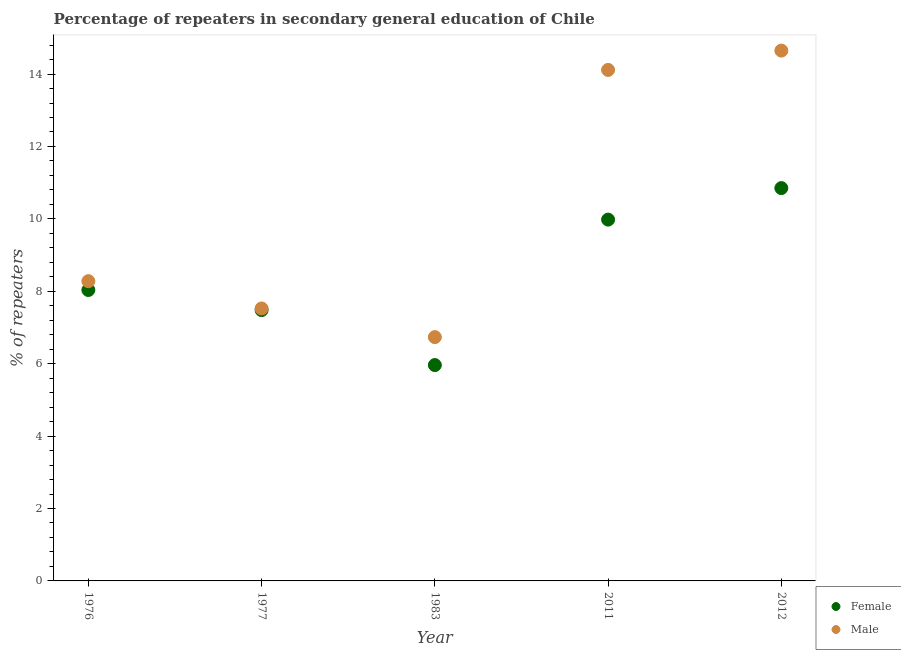How many different coloured dotlines are there?
Provide a short and direct response. 2. Is the number of dotlines equal to the number of legend labels?
Your response must be concise. Yes. What is the percentage of female repeaters in 2011?
Ensure brevity in your answer.  9.98. Across all years, what is the maximum percentage of male repeaters?
Ensure brevity in your answer.  14.65. Across all years, what is the minimum percentage of male repeaters?
Make the answer very short. 6.73. What is the total percentage of female repeaters in the graph?
Your response must be concise. 42.31. What is the difference between the percentage of female repeaters in 1976 and that in 1983?
Keep it short and to the point. 2.07. What is the difference between the percentage of male repeaters in 1983 and the percentage of female repeaters in 1977?
Your response must be concise. -0.75. What is the average percentage of male repeaters per year?
Offer a very short reply. 10.26. In the year 2011, what is the difference between the percentage of male repeaters and percentage of female repeaters?
Provide a short and direct response. 4.13. In how many years, is the percentage of female repeaters greater than 14.4 %?
Ensure brevity in your answer.  0. What is the ratio of the percentage of female repeaters in 1983 to that in 2012?
Provide a succinct answer. 0.55. Is the percentage of male repeaters in 1976 less than that in 1983?
Your response must be concise. No. What is the difference between the highest and the second highest percentage of male repeaters?
Your answer should be compact. 0.53. What is the difference between the highest and the lowest percentage of male repeaters?
Your response must be concise. 7.91. Is the sum of the percentage of female repeaters in 1983 and 2011 greater than the maximum percentage of male repeaters across all years?
Provide a short and direct response. Yes. Is the percentage of male repeaters strictly greater than the percentage of female repeaters over the years?
Provide a short and direct response. Yes. Is the percentage of female repeaters strictly less than the percentage of male repeaters over the years?
Your answer should be compact. Yes. How many years are there in the graph?
Keep it short and to the point. 5. Are the values on the major ticks of Y-axis written in scientific E-notation?
Your answer should be very brief. No. Does the graph contain grids?
Make the answer very short. No. How many legend labels are there?
Provide a succinct answer. 2. How are the legend labels stacked?
Your answer should be compact. Vertical. What is the title of the graph?
Keep it short and to the point. Percentage of repeaters in secondary general education of Chile. What is the label or title of the Y-axis?
Your response must be concise. % of repeaters. What is the % of repeaters of Female in 1976?
Your response must be concise. 8.04. What is the % of repeaters in Male in 1976?
Offer a very short reply. 8.28. What is the % of repeaters in Female in 1977?
Make the answer very short. 7.48. What is the % of repeaters in Male in 1977?
Provide a short and direct response. 7.53. What is the % of repeaters in Female in 1983?
Keep it short and to the point. 5.96. What is the % of repeaters in Male in 1983?
Make the answer very short. 6.73. What is the % of repeaters of Female in 2011?
Ensure brevity in your answer.  9.98. What is the % of repeaters in Male in 2011?
Keep it short and to the point. 14.11. What is the % of repeaters in Female in 2012?
Offer a terse response. 10.85. What is the % of repeaters of Male in 2012?
Provide a succinct answer. 14.65. Across all years, what is the maximum % of repeaters of Female?
Ensure brevity in your answer.  10.85. Across all years, what is the maximum % of repeaters of Male?
Provide a short and direct response. 14.65. Across all years, what is the minimum % of repeaters in Female?
Make the answer very short. 5.96. Across all years, what is the minimum % of repeaters in Male?
Your answer should be very brief. 6.73. What is the total % of repeaters in Female in the graph?
Your answer should be compact. 42.31. What is the total % of repeaters in Male in the graph?
Provide a short and direct response. 51.3. What is the difference between the % of repeaters in Female in 1976 and that in 1977?
Offer a terse response. 0.55. What is the difference between the % of repeaters in Male in 1976 and that in 1977?
Provide a short and direct response. 0.75. What is the difference between the % of repeaters in Female in 1976 and that in 1983?
Make the answer very short. 2.07. What is the difference between the % of repeaters in Male in 1976 and that in 1983?
Provide a succinct answer. 1.55. What is the difference between the % of repeaters in Female in 1976 and that in 2011?
Give a very brief answer. -1.94. What is the difference between the % of repeaters in Male in 1976 and that in 2011?
Make the answer very short. -5.83. What is the difference between the % of repeaters in Female in 1976 and that in 2012?
Your response must be concise. -2.81. What is the difference between the % of repeaters in Male in 1976 and that in 2012?
Offer a terse response. -6.37. What is the difference between the % of repeaters in Female in 1977 and that in 1983?
Make the answer very short. 1.52. What is the difference between the % of repeaters in Male in 1977 and that in 1983?
Provide a short and direct response. 0.79. What is the difference between the % of repeaters in Female in 1977 and that in 2011?
Your response must be concise. -2.5. What is the difference between the % of repeaters in Male in 1977 and that in 2011?
Your answer should be compact. -6.59. What is the difference between the % of repeaters of Female in 1977 and that in 2012?
Make the answer very short. -3.37. What is the difference between the % of repeaters of Male in 1977 and that in 2012?
Offer a very short reply. -7.12. What is the difference between the % of repeaters in Female in 1983 and that in 2011?
Your response must be concise. -4.02. What is the difference between the % of repeaters in Male in 1983 and that in 2011?
Your answer should be compact. -7.38. What is the difference between the % of repeaters of Female in 1983 and that in 2012?
Offer a very short reply. -4.89. What is the difference between the % of repeaters in Male in 1983 and that in 2012?
Provide a short and direct response. -7.91. What is the difference between the % of repeaters in Female in 2011 and that in 2012?
Your answer should be very brief. -0.87. What is the difference between the % of repeaters of Male in 2011 and that in 2012?
Provide a succinct answer. -0.53. What is the difference between the % of repeaters of Female in 1976 and the % of repeaters of Male in 1977?
Your response must be concise. 0.51. What is the difference between the % of repeaters in Female in 1976 and the % of repeaters in Male in 1983?
Give a very brief answer. 1.3. What is the difference between the % of repeaters in Female in 1976 and the % of repeaters in Male in 2011?
Provide a short and direct response. -6.08. What is the difference between the % of repeaters in Female in 1976 and the % of repeaters in Male in 2012?
Your answer should be very brief. -6.61. What is the difference between the % of repeaters in Female in 1977 and the % of repeaters in Male in 1983?
Your answer should be compact. 0.75. What is the difference between the % of repeaters in Female in 1977 and the % of repeaters in Male in 2011?
Make the answer very short. -6.63. What is the difference between the % of repeaters of Female in 1977 and the % of repeaters of Male in 2012?
Your answer should be compact. -7.17. What is the difference between the % of repeaters of Female in 1983 and the % of repeaters of Male in 2011?
Offer a terse response. -8.15. What is the difference between the % of repeaters in Female in 1983 and the % of repeaters in Male in 2012?
Offer a very short reply. -8.69. What is the difference between the % of repeaters in Female in 2011 and the % of repeaters in Male in 2012?
Offer a very short reply. -4.67. What is the average % of repeaters of Female per year?
Your response must be concise. 8.46. What is the average % of repeaters in Male per year?
Provide a succinct answer. 10.26. In the year 1976, what is the difference between the % of repeaters of Female and % of repeaters of Male?
Provide a short and direct response. -0.24. In the year 1977, what is the difference between the % of repeaters of Female and % of repeaters of Male?
Your answer should be compact. -0.04. In the year 1983, what is the difference between the % of repeaters of Female and % of repeaters of Male?
Ensure brevity in your answer.  -0.77. In the year 2011, what is the difference between the % of repeaters of Female and % of repeaters of Male?
Ensure brevity in your answer.  -4.13. In the year 2012, what is the difference between the % of repeaters in Female and % of repeaters in Male?
Your answer should be compact. -3.8. What is the ratio of the % of repeaters in Female in 1976 to that in 1977?
Keep it short and to the point. 1.07. What is the ratio of the % of repeaters in Male in 1976 to that in 1977?
Offer a very short reply. 1.1. What is the ratio of the % of repeaters of Female in 1976 to that in 1983?
Make the answer very short. 1.35. What is the ratio of the % of repeaters of Male in 1976 to that in 1983?
Provide a succinct answer. 1.23. What is the ratio of the % of repeaters in Female in 1976 to that in 2011?
Give a very brief answer. 0.81. What is the ratio of the % of repeaters of Male in 1976 to that in 2011?
Your answer should be very brief. 0.59. What is the ratio of the % of repeaters of Female in 1976 to that in 2012?
Your response must be concise. 0.74. What is the ratio of the % of repeaters in Male in 1976 to that in 2012?
Keep it short and to the point. 0.57. What is the ratio of the % of repeaters in Female in 1977 to that in 1983?
Your answer should be very brief. 1.25. What is the ratio of the % of repeaters of Male in 1977 to that in 1983?
Offer a very short reply. 1.12. What is the ratio of the % of repeaters of Female in 1977 to that in 2011?
Your answer should be compact. 0.75. What is the ratio of the % of repeaters in Male in 1977 to that in 2011?
Your answer should be very brief. 0.53. What is the ratio of the % of repeaters of Female in 1977 to that in 2012?
Your answer should be compact. 0.69. What is the ratio of the % of repeaters of Male in 1977 to that in 2012?
Give a very brief answer. 0.51. What is the ratio of the % of repeaters in Female in 1983 to that in 2011?
Keep it short and to the point. 0.6. What is the ratio of the % of repeaters in Male in 1983 to that in 2011?
Offer a very short reply. 0.48. What is the ratio of the % of repeaters of Female in 1983 to that in 2012?
Keep it short and to the point. 0.55. What is the ratio of the % of repeaters of Male in 1983 to that in 2012?
Ensure brevity in your answer.  0.46. What is the ratio of the % of repeaters in Female in 2011 to that in 2012?
Offer a terse response. 0.92. What is the ratio of the % of repeaters in Male in 2011 to that in 2012?
Your response must be concise. 0.96. What is the difference between the highest and the second highest % of repeaters in Female?
Keep it short and to the point. 0.87. What is the difference between the highest and the second highest % of repeaters of Male?
Provide a succinct answer. 0.53. What is the difference between the highest and the lowest % of repeaters of Female?
Keep it short and to the point. 4.89. What is the difference between the highest and the lowest % of repeaters in Male?
Offer a very short reply. 7.91. 